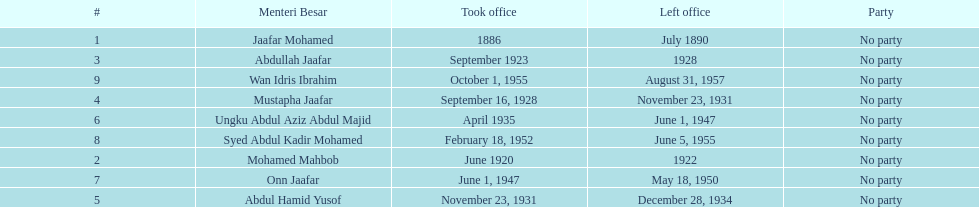Who spend the most amount of time in office? Ungku Abdul Aziz Abdul Majid. Can you parse all the data within this table? {'header': ['#', 'Menteri Besar', 'Took office', 'Left office', 'Party'], 'rows': [['1', 'Jaafar Mohamed', '1886', 'July 1890', 'No party'], ['3', 'Abdullah Jaafar', 'September 1923', '1928', 'No party'], ['9', 'Wan Idris Ibrahim', 'October 1, 1955', 'August 31, 1957', 'No party'], ['4', 'Mustapha Jaafar', 'September 16, 1928', 'November 23, 1931', 'No party'], ['6', 'Ungku Abdul Aziz Abdul Majid', 'April 1935', 'June 1, 1947', 'No party'], ['8', 'Syed Abdul Kadir Mohamed', 'February 18, 1952', 'June 5, 1955', 'No party'], ['2', 'Mohamed Mahbob', 'June 1920', '1922', 'No party'], ['7', 'Onn Jaafar', 'June 1, 1947', 'May 18, 1950', 'No party'], ['5', 'Abdul Hamid Yusof', 'November 23, 1931', 'December 28, 1934', 'No party']]} 